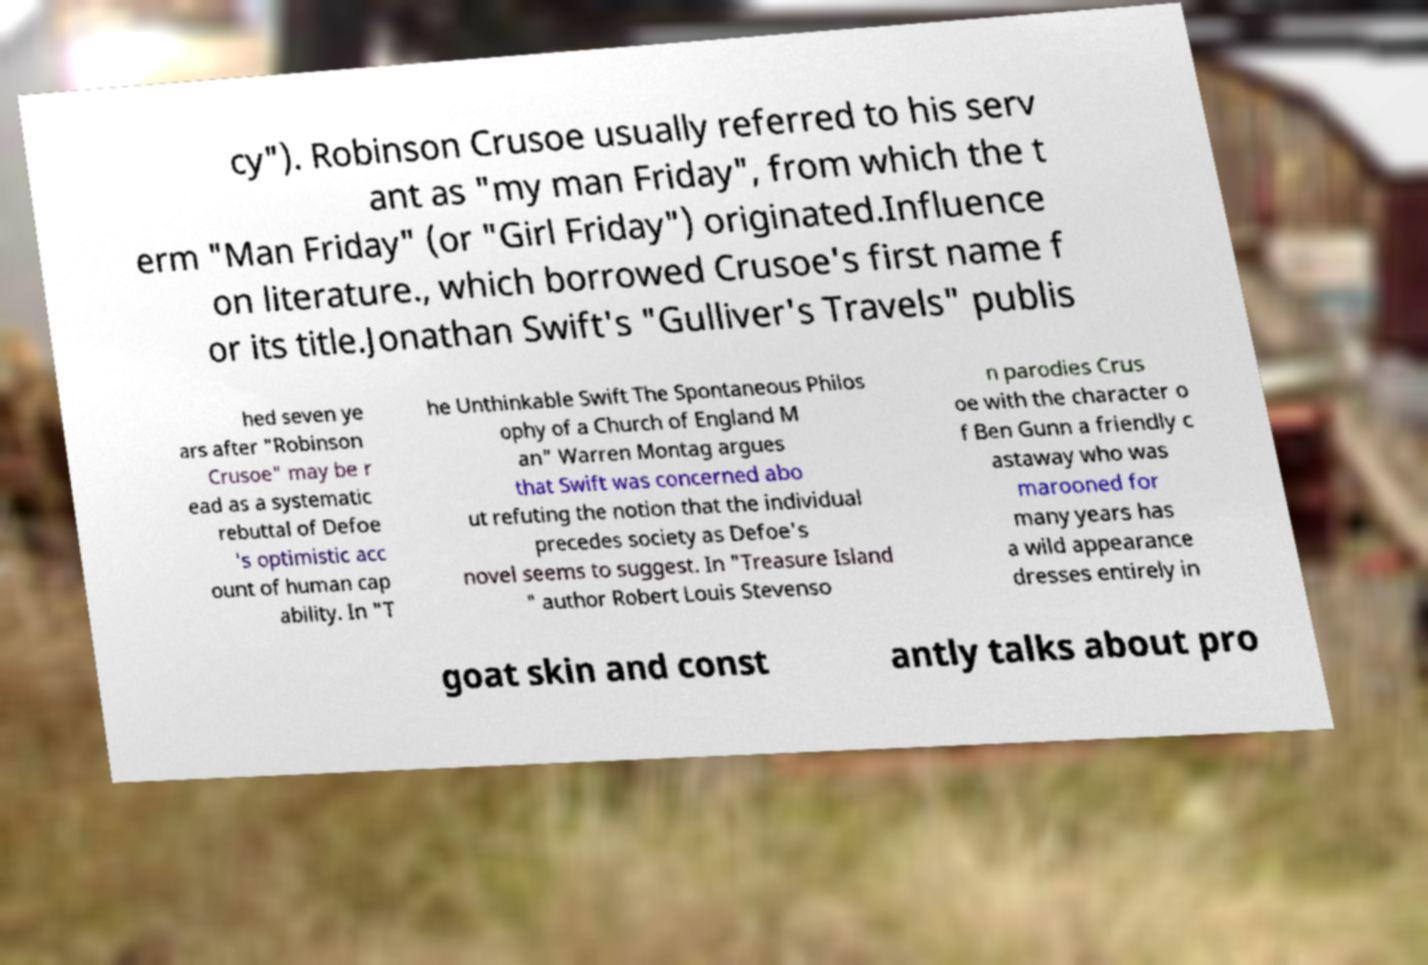There's text embedded in this image that I need extracted. Can you transcribe it verbatim? cy"). Robinson Crusoe usually referred to his serv ant as "my man Friday", from which the t erm "Man Friday" (or "Girl Friday") originated.Influence on literature., which borrowed Crusoe's first name f or its title.Jonathan Swift's "Gulliver's Travels" publis hed seven ye ars after "Robinson Crusoe" may be r ead as a systematic rebuttal of Defoe 's optimistic acc ount of human cap ability. In "T he Unthinkable Swift The Spontaneous Philos ophy of a Church of England M an" Warren Montag argues that Swift was concerned abo ut refuting the notion that the individual precedes society as Defoe's novel seems to suggest. In "Treasure Island " author Robert Louis Stevenso n parodies Crus oe with the character o f Ben Gunn a friendly c astaway who was marooned for many years has a wild appearance dresses entirely in goat skin and const antly talks about pro 